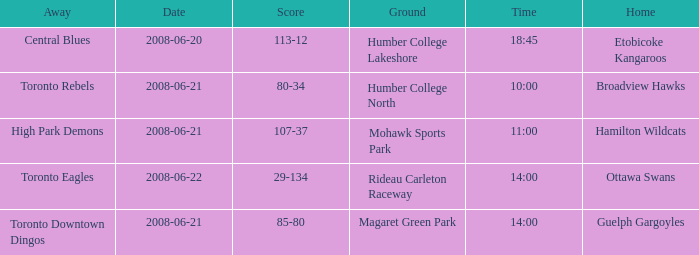What is the Date with a Home that is hamilton wildcats? 2008-06-21. 